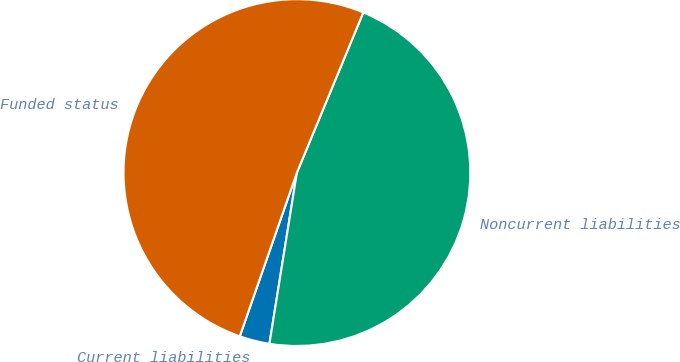<chart> <loc_0><loc_0><loc_500><loc_500><pie_chart><fcel>Current liabilities<fcel>Noncurrent liabilities<fcel>Funded status<nl><fcel>2.81%<fcel>46.28%<fcel>50.91%<nl></chart> 